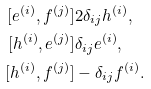Convert formula to latex. <formula><loc_0><loc_0><loc_500><loc_500>[ e ^ { ( i ) } , f ^ { ( j ) } ] & 2 \delta _ { i j } h ^ { ( i ) } , \\ [ h ^ { ( i ) } , e ^ { ( j ) } ] & \delta _ { i j } e ^ { ( i ) } , \\ [ h ^ { ( i ) } , f ^ { ( j ) } ] & - \delta _ { i j } f ^ { ( i ) } .</formula> 